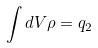Convert formula to latex. <formula><loc_0><loc_0><loc_500><loc_500>\int d V \rho = q _ { 2 }</formula> 